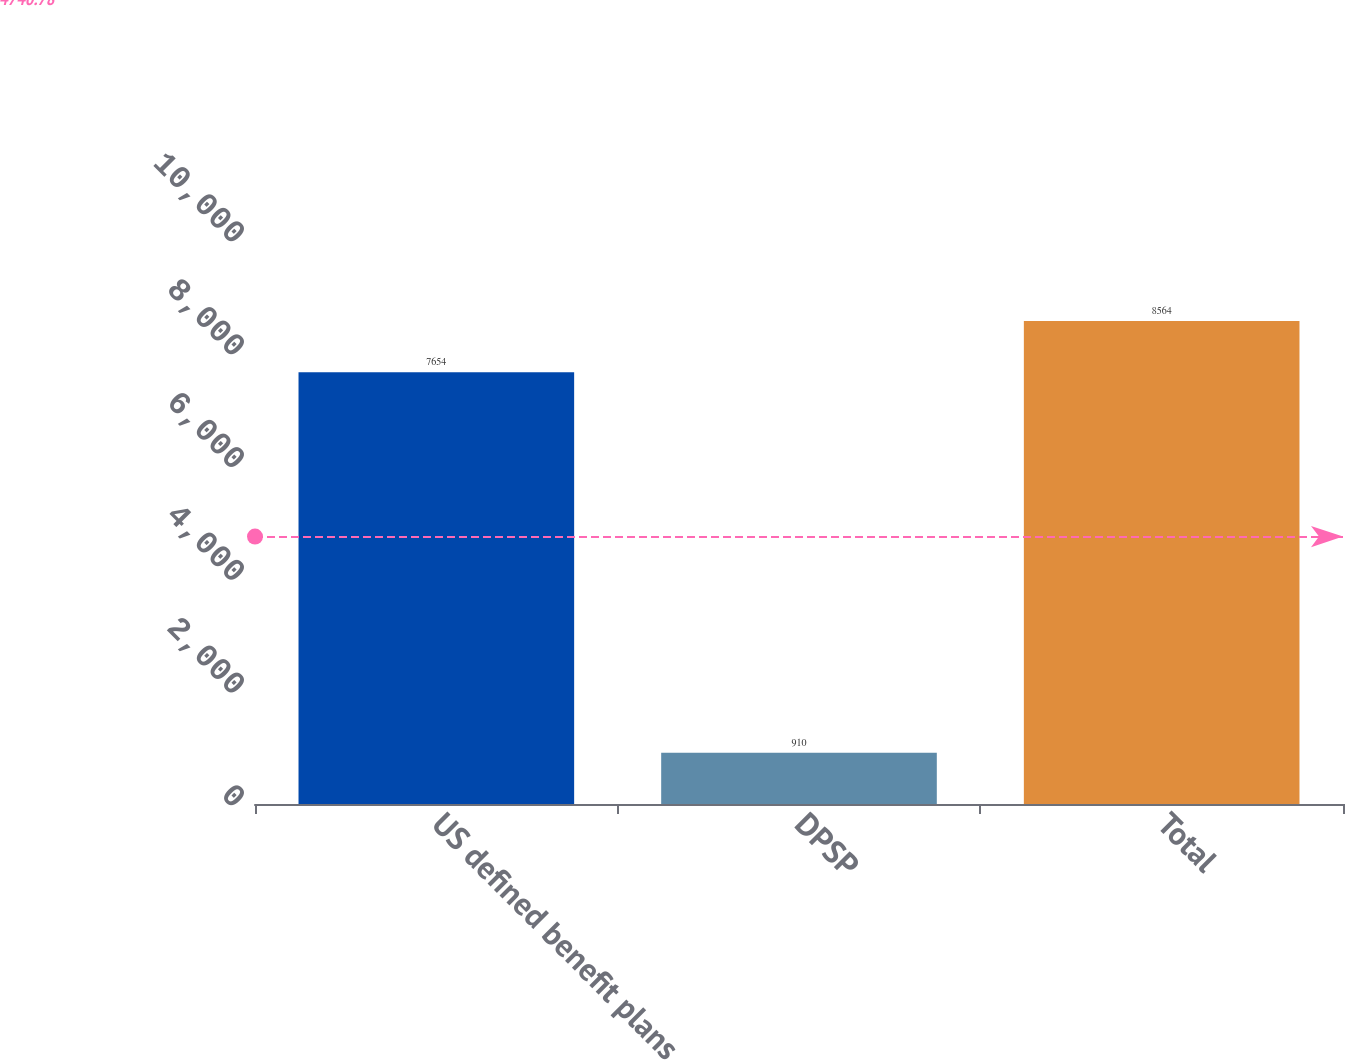Convert chart. <chart><loc_0><loc_0><loc_500><loc_500><bar_chart><fcel>US defined benefit plans<fcel>DPSP<fcel>Total<nl><fcel>7654<fcel>910<fcel>8564<nl></chart> 